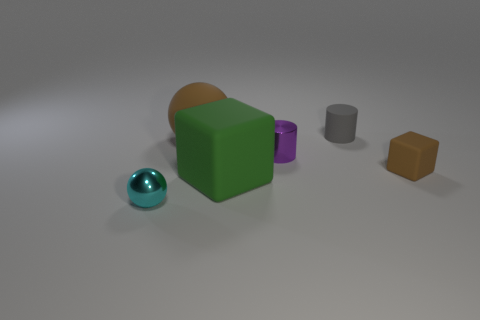How many objects are there in the image, and can you categorize them? There are six objects in the image. We can categorize them as follows: two spherical objects (one cyan and one orange), two cubical objects (one green and one yellowish-brown), and two cylindrical objects (one purple and one grey). The objects vary in size and texture, giving an impression of diversity. Is there any sense of order or pattern to how the objects are arranged? The objects seem to be arranged with no specific pattern, but their placement creates a balanced composition. There’s a mix of colors and shapes that are randomly placed, yet they collectively contribute to a harmonious visual balance, perhaps intentionally arranged to offer a pleasing aesthetic or to serve as a study in geometry and color. 